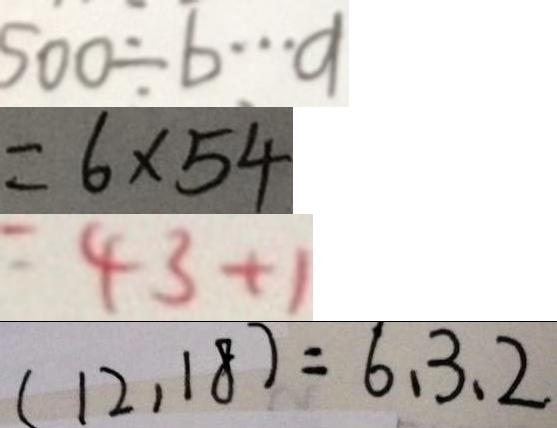Convert formula to latex. <formula><loc_0><loc_0><loc_500><loc_500>5 0 0 \div b \cdots a 
 = 6 \times 5 4 
 = 4 3 + 1 
 ( 1 2 , 1 8 ) = 6 、 3 、 2</formula> 